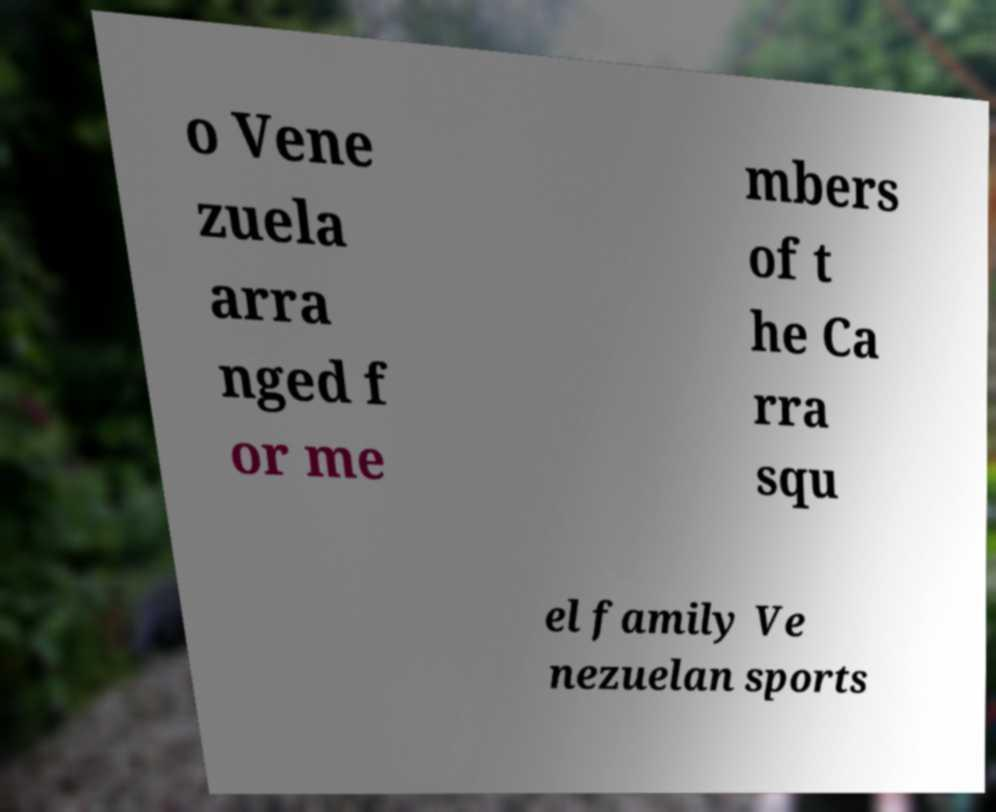Can you read and provide the text displayed in the image?This photo seems to have some interesting text. Can you extract and type it out for me? o Vene zuela arra nged f or me mbers of t he Ca rra squ el family Ve nezuelan sports 